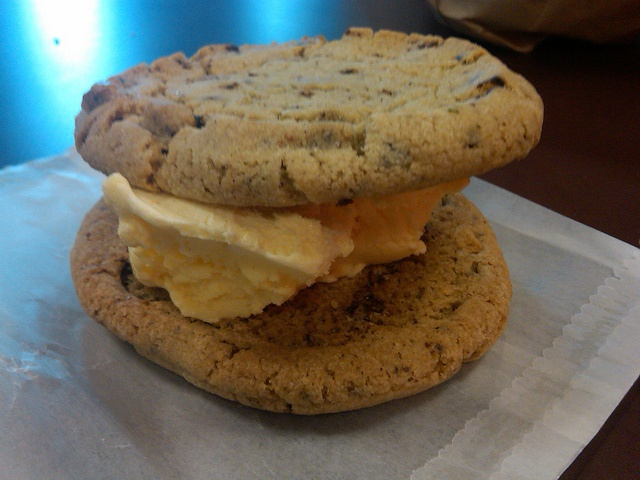Describe the objects in this image and their specific colors. I can see a sandwich in lightblue, maroon, tan, and olive tones in this image. 